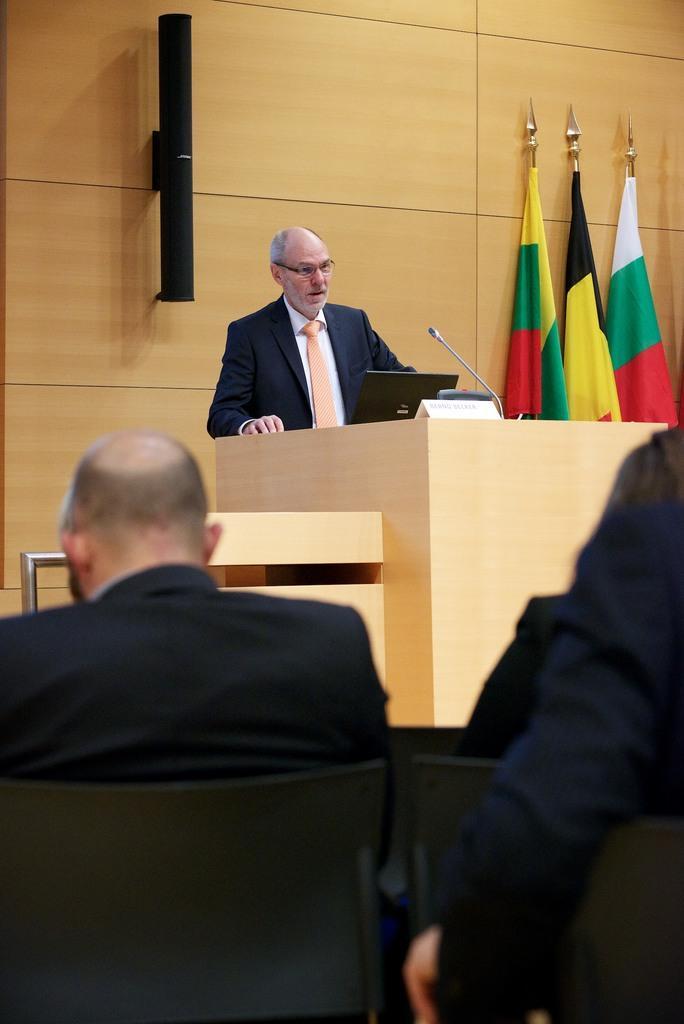Describe this image in one or two sentences. In this picture can see a man wearing spectacles, blazer, tie and he is standing near to a podium. On the podium we can see a laptop, mic and a board. In the background we can see flags. We can see people sitting on the chairs. 